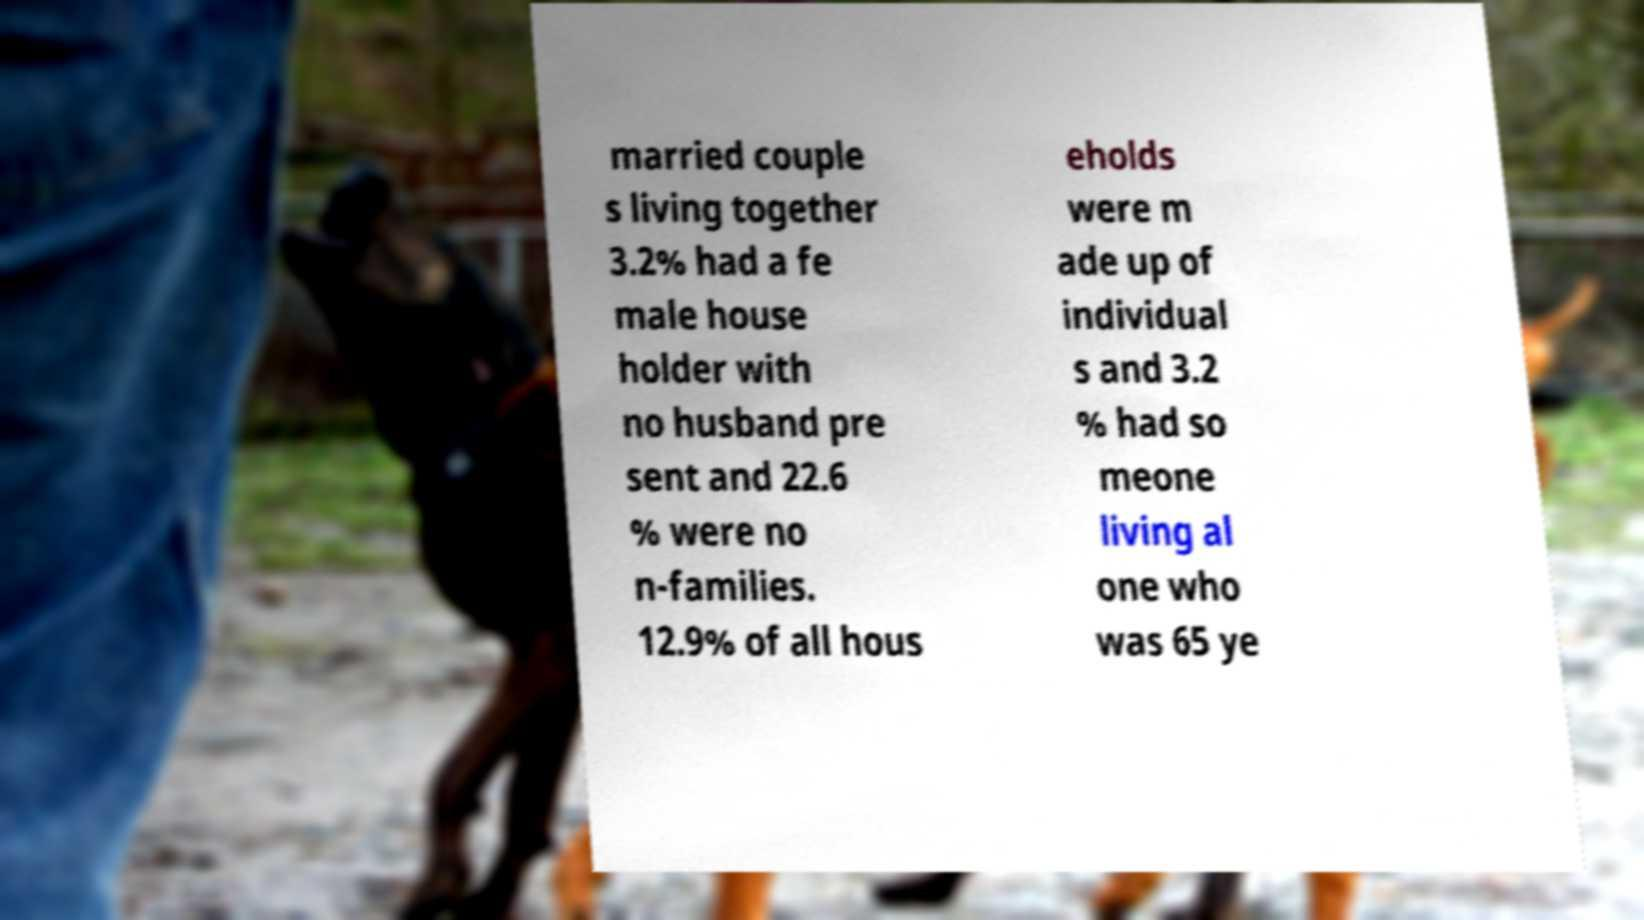Can you read and provide the text displayed in the image?This photo seems to have some interesting text. Can you extract and type it out for me? married couple s living together 3.2% had a fe male house holder with no husband pre sent and 22.6 % were no n-families. 12.9% of all hous eholds were m ade up of individual s and 3.2 % had so meone living al one who was 65 ye 